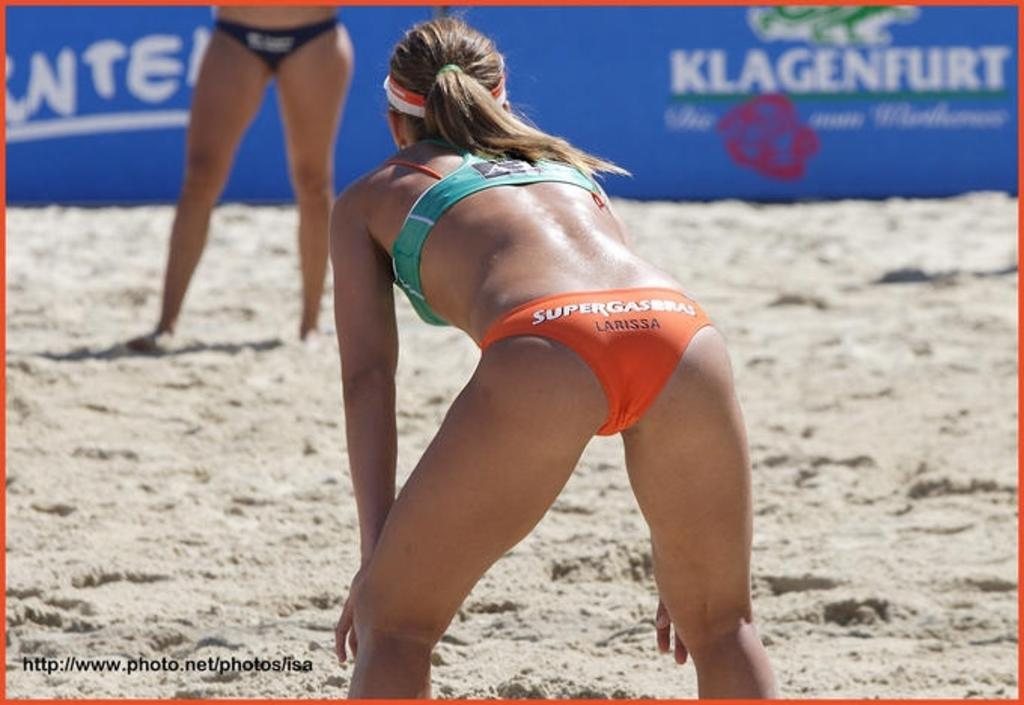What is the main subject of the image? There is a person standing in the image. Can you describe the person's attire? The person is wearing a green and orange color dress. Are there any other people visible in the image? Yes, there is another person standing in the background of the image. What can be seen in the background of the image besides the other person? There is a blue color banner visible in the background of the image. What type of development is the person rubbing with a hammer in the image? There is no development or hammer present in the image. 